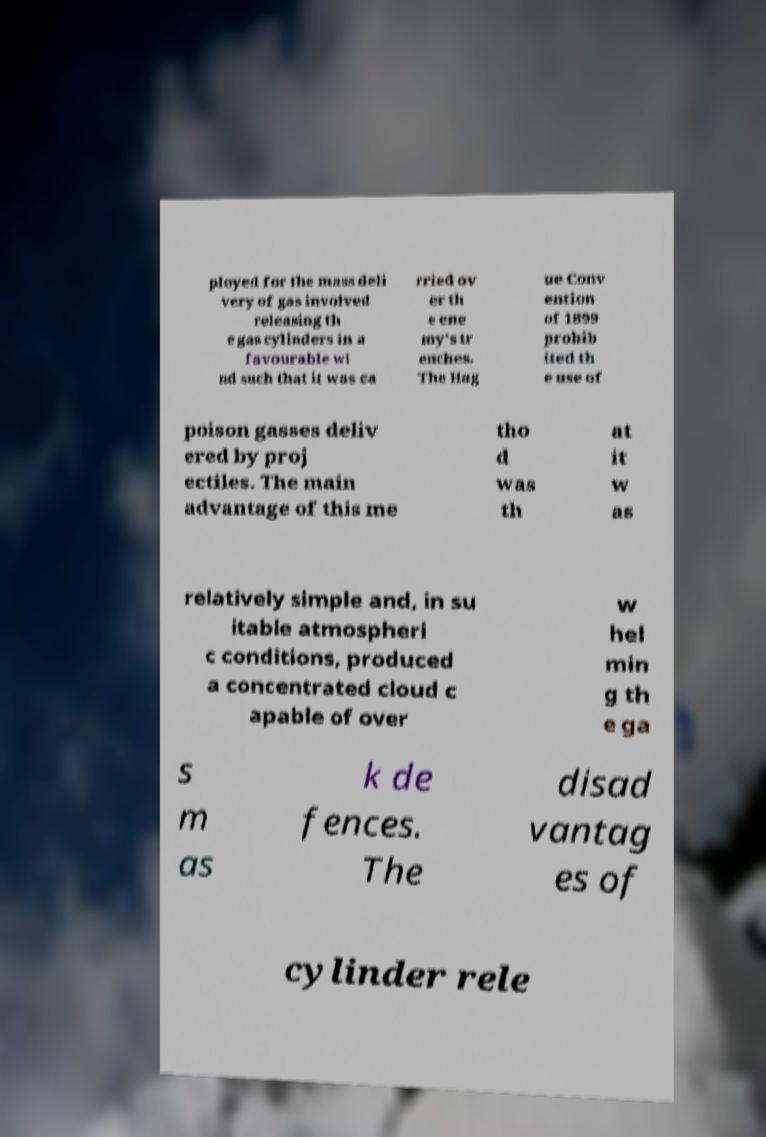Can you read and provide the text displayed in the image?This photo seems to have some interesting text. Can you extract and type it out for me? ployed for the mass deli very of gas involved releasing th e gas cylinders in a favourable wi nd such that it was ca rried ov er th e ene my's tr enches. The Hag ue Conv ention of 1899 prohib ited th e use of poison gasses deliv ered by proj ectiles. The main advantage of this me tho d was th at it w as relatively simple and, in su itable atmospheri c conditions, produced a concentrated cloud c apable of over w hel min g th e ga s m as k de fences. The disad vantag es of cylinder rele 